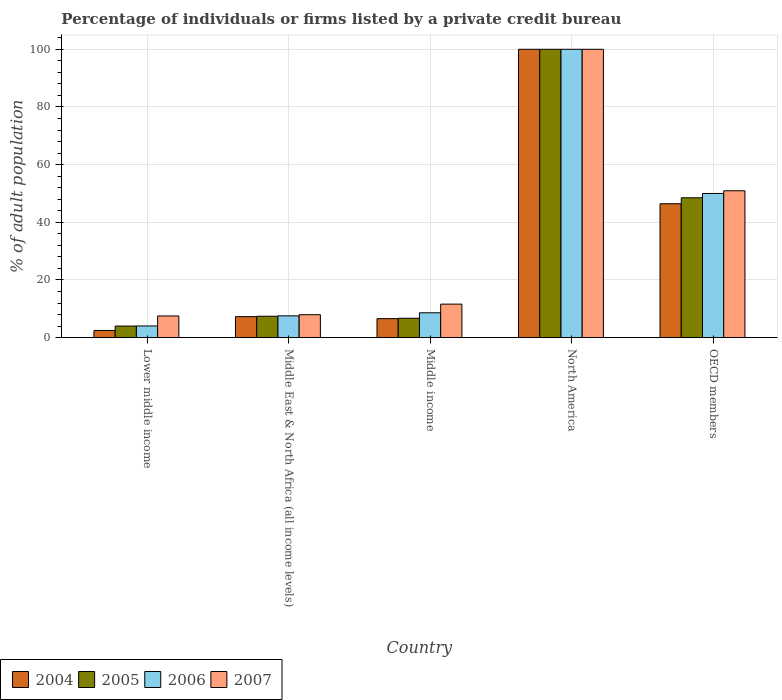How many groups of bars are there?
Offer a terse response. 5. Are the number of bars on each tick of the X-axis equal?
Keep it short and to the point. Yes. How many bars are there on the 1st tick from the left?
Offer a very short reply. 4. How many bars are there on the 4th tick from the right?
Your answer should be very brief. 4. What is the label of the 5th group of bars from the left?
Your answer should be compact. OECD members. In how many cases, is the number of bars for a given country not equal to the number of legend labels?
Your answer should be compact. 0. What is the percentage of population listed by a private credit bureau in 2004 in OECD members?
Offer a very short reply. 46.43. Across all countries, what is the minimum percentage of population listed by a private credit bureau in 2004?
Your response must be concise. 2.5. In which country was the percentage of population listed by a private credit bureau in 2004 maximum?
Provide a succinct answer. North America. In which country was the percentage of population listed by a private credit bureau in 2004 minimum?
Provide a succinct answer. Lower middle income. What is the total percentage of population listed by a private credit bureau in 2006 in the graph?
Ensure brevity in your answer.  170.25. What is the difference between the percentage of population listed by a private credit bureau in 2004 in Middle income and that in OECD members?
Make the answer very short. -39.84. What is the difference between the percentage of population listed by a private credit bureau in 2006 in Middle income and the percentage of population listed by a private credit bureau in 2005 in OECD members?
Keep it short and to the point. -39.88. What is the average percentage of population listed by a private credit bureau in 2004 per country?
Give a very brief answer. 32.56. What is the difference between the percentage of population listed by a private credit bureau of/in 2005 and percentage of population listed by a private credit bureau of/in 2006 in OECD members?
Ensure brevity in your answer.  -1.5. In how many countries, is the percentage of population listed by a private credit bureau in 2005 greater than 92 %?
Provide a succinct answer. 1. What is the ratio of the percentage of population listed by a private credit bureau in 2006 in Middle income to that in OECD members?
Make the answer very short. 0.17. Is the difference between the percentage of population listed by a private credit bureau in 2005 in Lower middle income and Middle East & North Africa (all income levels) greater than the difference between the percentage of population listed by a private credit bureau in 2006 in Lower middle income and Middle East & North Africa (all income levels)?
Provide a succinct answer. Yes. What is the difference between the highest and the second highest percentage of population listed by a private credit bureau in 2006?
Provide a succinct answer. -41.38. What is the difference between the highest and the lowest percentage of population listed by a private credit bureau in 2005?
Your response must be concise. 95.97. Is it the case that in every country, the sum of the percentage of population listed by a private credit bureau in 2006 and percentage of population listed by a private credit bureau in 2007 is greater than the sum of percentage of population listed by a private credit bureau in 2004 and percentage of population listed by a private credit bureau in 2005?
Offer a terse response. No. What does the 1st bar from the right in Middle income represents?
Your response must be concise. 2007. Is it the case that in every country, the sum of the percentage of population listed by a private credit bureau in 2007 and percentage of population listed by a private credit bureau in 2005 is greater than the percentage of population listed by a private credit bureau in 2004?
Make the answer very short. Yes. How many bars are there?
Keep it short and to the point. 20. Are all the bars in the graph horizontal?
Your answer should be compact. No. Does the graph contain grids?
Your answer should be very brief. Yes. What is the title of the graph?
Your answer should be very brief. Percentage of individuals or firms listed by a private credit bureau. What is the label or title of the Y-axis?
Ensure brevity in your answer.  % of adult population. What is the % of adult population of 2004 in Lower middle income?
Give a very brief answer. 2.5. What is the % of adult population in 2005 in Lower middle income?
Provide a short and direct response. 4.03. What is the % of adult population of 2006 in Lower middle income?
Provide a short and direct response. 4.06. What is the % of adult population in 2007 in Lower middle income?
Offer a terse response. 7.53. What is the % of adult population in 2004 in Middle East & North Africa (all income levels)?
Give a very brief answer. 7.29. What is the % of adult population of 2005 in Middle East & North Africa (all income levels)?
Provide a succinct answer. 7.43. What is the % of adult population in 2006 in Middle East & North Africa (all income levels)?
Your answer should be compact. 7.56. What is the % of adult population of 2007 in Middle East & North Africa (all income levels)?
Give a very brief answer. 7.96. What is the % of adult population in 2004 in Middle income?
Your answer should be compact. 6.6. What is the % of adult population in 2005 in Middle income?
Give a very brief answer. 6.73. What is the % of adult population of 2006 in Middle income?
Your answer should be very brief. 8.62. What is the % of adult population of 2007 in Middle income?
Provide a short and direct response. 11.63. What is the % of adult population of 2004 in North America?
Ensure brevity in your answer.  100. What is the % of adult population of 2006 in North America?
Ensure brevity in your answer.  100. What is the % of adult population in 2004 in OECD members?
Provide a succinct answer. 46.43. What is the % of adult population in 2005 in OECD members?
Provide a short and direct response. 48.5. What is the % of adult population of 2006 in OECD members?
Give a very brief answer. 50. What is the % of adult population in 2007 in OECD members?
Your answer should be very brief. 50.95. Across all countries, what is the maximum % of adult population of 2004?
Your answer should be compact. 100. Across all countries, what is the minimum % of adult population of 2004?
Give a very brief answer. 2.5. Across all countries, what is the minimum % of adult population of 2005?
Make the answer very short. 4.03. Across all countries, what is the minimum % of adult population in 2006?
Provide a short and direct response. 4.06. Across all countries, what is the minimum % of adult population in 2007?
Give a very brief answer. 7.53. What is the total % of adult population in 2004 in the graph?
Offer a very short reply. 162.82. What is the total % of adult population in 2005 in the graph?
Provide a succinct answer. 166.69. What is the total % of adult population of 2006 in the graph?
Give a very brief answer. 170.25. What is the total % of adult population of 2007 in the graph?
Give a very brief answer. 178.07. What is the difference between the % of adult population in 2004 in Lower middle income and that in Middle East & North Africa (all income levels)?
Provide a short and direct response. -4.79. What is the difference between the % of adult population in 2005 in Lower middle income and that in Middle East & North Africa (all income levels)?
Keep it short and to the point. -3.4. What is the difference between the % of adult population of 2006 in Lower middle income and that in Middle East & North Africa (all income levels)?
Keep it short and to the point. -3.51. What is the difference between the % of adult population in 2007 in Lower middle income and that in Middle East & North Africa (all income levels)?
Make the answer very short. -0.44. What is the difference between the % of adult population in 2004 in Lower middle income and that in Middle income?
Keep it short and to the point. -4.09. What is the difference between the % of adult population of 2005 in Lower middle income and that in Middle income?
Offer a terse response. -2.7. What is the difference between the % of adult population of 2006 in Lower middle income and that in Middle income?
Your answer should be compact. -4.57. What is the difference between the % of adult population in 2007 in Lower middle income and that in Middle income?
Make the answer very short. -4.11. What is the difference between the % of adult population in 2004 in Lower middle income and that in North America?
Your answer should be very brief. -97.5. What is the difference between the % of adult population in 2005 in Lower middle income and that in North America?
Keep it short and to the point. -95.97. What is the difference between the % of adult population in 2006 in Lower middle income and that in North America?
Give a very brief answer. -95.94. What is the difference between the % of adult population of 2007 in Lower middle income and that in North America?
Make the answer very short. -92.47. What is the difference between the % of adult population of 2004 in Lower middle income and that in OECD members?
Ensure brevity in your answer.  -43.93. What is the difference between the % of adult population of 2005 in Lower middle income and that in OECD members?
Provide a succinct answer. -44.48. What is the difference between the % of adult population of 2006 in Lower middle income and that in OECD members?
Your answer should be compact. -45.94. What is the difference between the % of adult population of 2007 in Lower middle income and that in OECD members?
Make the answer very short. -43.42. What is the difference between the % of adult population in 2004 in Middle East & North Africa (all income levels) and that in Middle income?
Provide a short and direct response. 0.69. What is the difference between the % of adult population in 2005 in Middle East & North Africa (all income levels) and that in Middle income?
Keep it short and to the point. 0.7. What is the difference between the % of adult population of 2006 in Middle East & North Africa (all income levels) and that in Middle income?
Offer a terse response. -1.06. What is the difference between the % of adult population of 2007 in Middle East & North Africa (all income levels) and that in Middle income?
Keep it short and to the point. -3.67. What is the difference between the % of adult population of 2004 in Middle East & North Africa (all income levels) and that in North America?
Ensure brevity in your answer.  -92.71. What is the difference between the % of adult population of 2005 in Middle East & North Africa (all income levels) and that in North America?
Your answer should be compact. -92.57. What is the difference between the % of adult population in 2006 in Middle East & North Africa (all income levels) and that in North America?
Provide a short and direct response. -92.44. What is the difference between the % of adult population in 2007 in Middle East & North Africa (all income levels) and that in North America?
Your response must be concise. -92.04. What is the difference between the % of adult population in 2004 in Middle East & North Africa (all income levels) and that in OECD members?
Your response must be concise. -39.15. What is the difference between the % of adult population in 2005 in Middle East & North Africa (all income levels) and that in OECD members?
Your answer should be compact. -41.07. What is the difference between the % of adult population of 2006 in Middle East & North Africa (all income levels) and that in OECD members?
Provide a succinct answer. -42.44. What is the difference between the % of adult population in 2007 in Middle East & North Africa (all income levels) and that in OECD members?
Ensure brevity in your answer.  -42.98. What is the difference between the % of adult population of 2004 in Middle income and that in North America?
Your response must be concise. -93.4. What is the difference between the % of adult population of 2005 in Middle income and that in North America?
Your answer should be compact. -93.27. What is the difference between the % of adult population in 2006 in Middle income and that in North America?
Provide a short and direct response. -91.38. What is the difference between the % of adult population of 2007 in Middle income and that in North America?
Your answer should be compact. -88.37. What is the difference between the % of adult population in 2004 in Middle income and that in OECD members?
Your response must be concise. -39.84. What is the difference between the % of adult population in 2005 in Middle income and that in OECD members?
Offer a terse response. -41.77. What is the difference between the % of adult population in 2006 in Middle income and that in OECD members?
Ensure brevity in your answer.  -41.38. What is the difference between the % of adult population of 2007 in Middle income and that in OECD members?
Provide a succinct answer. -39.31. What is the difference between the % of adult population of 2004 in North America and that in OECD members?
Provide a short and direct response. 53.57. What is the difference between the % of adult population in 2005 in North America and that in OECD members?
Offer a terse response. 51.5. What is the difference between the % of adult population in 2007 in North America and that in OECD members?
Your response must be concise. 49.05. What is the difference between the % of adult population in 2004 in Lower middle income and the % of adult population in 2005 in Middle East & North Africa (all income levels)?
Keep it short and to the point. -4.93. What is the difference between the % of adult population of 2004 in Lower middle income and the % of adult population of 2006 in Middle East & North Africa (all income levels)?
Provide a succinct answer. -5.06. What is the difference between the % of adult population in 2004 in Lower middle income and the % of adult population in 2007 in Middle East & North Africa (all income levels)?
Offer a terse response. -5.46. What is the difference between the % of adult population in 2005 in Lower middle income and the % of adult population in 2006 in Middle East & North Africa (all income levels)?
Ensure brevity in your answer.  -3.54. What is the difference between the % of adult population in 2005 in Lower middle income and the % of adult population in 2007 in Middle East & North Africa (all income levels)?
Your answer should be compact. -3.94. What is the difference between the % of adult population in 2006 in Lower middle income and the % of adult population in 2007 in Middle East & North Africa (all income levels)?
Offer a very short reply. -3.9. What is the difference between the % of adult population of 2004 in Lower middle income and the % of adult population of 2005 in Middle income?
Your answer should be very brief. -4.23. What is the difference between the % of adult population of 2004 in Lower middle income and the % of adult population of 2006 in Middle income?
Provide a succinct answer. -6.12. What is the difference between the % of adult population in 2004 in Lower middle income and the % of adult population in 2007 in Middle income?
Offer a terse response. -9.13. What is the difference between the % of adult population in 2005 in Lower middle income and the % of adult population in 2006 in Middle income?
Ensure brevity in your answer.  -4.6. What is the difference between the % of adult population of 2005 in Lower middle income and the % of adult population of 2007 in Middle income?
Provide a short and direct response. -7.61. What is the difference between the % of adult population of 2006 in Lower middle income and the % of adult population of 2007 in Middle income?
Keep it short and to the point. -7.58. What is the difference between the % of adult population in 2004 in Lower middle income and the % of adult population in 2005 in North America?
Give a very brief answer. -97.5. What is the difference between the % of adult population of 2004 in Lower middle income and the % of adult population of 2006 in North America?
Make the answer very short. -97.5. What is the difference between the % of adult population in 2004 in Lower middle income and the % of adult population in 2007 in North America?
Offer a very short reply. -97.5. What is the difference between the % of adult population in 2005 in Lower middle income and the % of adult population in 2006 in North America?
Make the answer very short. -95.97. What is the difference between the % of adult population of 2005 in Lower middle income and the % of adult population of 2007 in North America?
Ensure brevity in your answer.  -95.97. What is the difference between the % of adult population of 2006 in Lower middle income and the % of adult population of 2007 in North America?
Your answer should be compact. -95.94. What is the difference between the % of adult population in 2004 in Lower middle income and the % of adult population in 2005 in OECD members?
Make the answer very short. -46. What is the difference between the % of adult population in 2004 in Lower middle income and the % of adult population in 2006 in OECD members?
Give a very brief answer. -47.5. What is the difference between the % of adult population of 2004 in Lower middle income and the % of adult population of 2007 in OECD members?
Offer a very short reply. -48.44. What is the difference between the % of adult population of 2005 in Lower middle income and the % of adult population of 2006 in OECD members?
Provide a succinct answer. -45.98. What is the difference between the % of adult population of 2005 in Lower middle income and the % of adult population of 2007 in OECD members?
Your response must be concise. -46.92. What is the difference between the % of adult population in 2006 in Lower middle income and the % of adult population in 2007 in OECD members?
Ensure brevity in your answer.  -46.89. What is the difference between the % of adult population of 2004 in Middle East & North Africa (all income levels) and the % of adult population of 2005 in Middle income?
Offer a very short reply. 0.56. What is the difference between the % of adult population of 2004 in Middle East & North Africa (all income levels) and the % of adult population of 2006 in Middle income?
Make the answer very short. -1.34. What is the difference between the % of adult population in 2004 in Middle East & North Africa (all income levels) and the % of adult population in 2007 in Middle income?
Keep it short and to the point. -4.35. What is the difference between the % of adult population of 2005 in Middle East & North Africa (all income levels) and the % of adult population of 2006 in Middle income?
Ensure brevity in your answer.  -1.2. What is the difference between the % of adult population of 2005 in Middle East & North Africa (all income levels) and the % of adult population of 2007 in Middle income?
Make the answer very short. -4.21. What is the difference between the % of adult population in 2006 in Middle East & North Africa (all income levels) and the % of adult population in 2007 in Middle income?
Offer a terse response. -4.07. What is the difference between the % of adult population of 2004 in Middle East & North Africa (all income levels) and the % of adult population of 2005 in North America?
Ensure brevity in your answer.  -92.71. What is the difference between the % of adult population of 2004 in Middle East & North Africa (all income levels) and the % of adult population of 2006 in North America?
Your response must be concise. -92.71. What is the difference between the % of adult population of 2004 in Middle East & North Africa (all income levels) and the % of adult population of 2007 in North America?
Your response must be concise. -92.71. What is the difference between the % of adult population of 2005 in Middle East & North Africa (all income levels) and the % of adult population of 2006 in North America?
Make the answer very short. -92.57. What is the difference between the % of adult population of 2005 in Middle East & North Africa (all income levels) and the % of adult population of 2007 in North America?
Give a very brief answer. -92.57. What is the difference between the % of adult population of 2006 in Middle East & North Africa (all income levels) and the % of adult population of 2007 in North America?
Your response must be concise. -92.44. What is the difference between the % of adult population of 2004 in Middle East & North Africa (all income levels) and the % of adult population of 2005 in OECD members?
Provide a short and direct response. -41.22. What is the difference between the % of adult population in 2004 in Middle East & North Africa (all income levels) and the % of adult population in 2006 in OECD members?
Offer a terse response. -42.71. What is the difference between the % of adult population of 2004 in Middle East & North Africa (all income levels) and the % of adult population of 2007 in OECD members?
Your answer should be very brief. -43.66. What is the difference between the % of adult population of 2005 in Middle East & North Africa (all income levels) and the % of adult population of 2006 in OECD members?
Provide a succinct answer. -42.57. What is the difference between the % of adult population of 2005 in Middle East & North Africa (all income levels) and the % of adult population of 2007 in OECD members?
Your answer should be very brief. -43.52. What is the difference between the % of adult population of 2006 in Middle East & North Africa (all income levels) and the % of adult population of 2007 in OECD members?
Offer a very short reply. -43.38. What is the difference between the % of adult population in 2004 in Middle income and the % of adult population in 2005 in North America?
Ensure brevity in your answer.  -93.4. What is the difference between the % of adult population in 2004 in Middle income and the % of adult population in 2006 in North America?
Provide a succinct answer. -93.4. What is the difference between the % of adult population of 2004 in Middle income and the % of adult population of 2007 in North America?
Provide a succinct answer. -93.4. What is the difference between the % of adult population of 2005 in Middle income and the % of adult population of 2006 in North America?
Give a very brief answer. -93.27. What is the difference between the % of adult population in 2005 in Middle income and the % of adult population in 2007 in North America?
Keep it short and to the point. -93.27. What is the difference between the % of adult population in 2006 in Middle income and the % of adult population in 2007 in North America?
Your answer should be compact. -91.38. What is the difference between the % of adult population of 2004 in Middle income and the % of adult population of 2005 in OECD members?
Offer a terse response. -41.91. What is the difference between the % of adult population of 2004 in Middle income and the % of adult population of 2006 in OECD members?
Provide a short and direct response. -43.4. What is the difference between the % of adult population in 2004 in Middle income and the % of adult population in 2007 in OECD members?
Make the answer very short. -44.35. What is the difference between the % of adult population of 2005 in Middle income and the % of adult population of 2006 in OECD members?
Ensure brevity in your answer.  -43.27. What is the difference between the % of adult population in 2005 in Middle income and the % of adult population in 2007 in OECD members?
Provide a short and direct response. -44.22. What is the difference between the % of adult population of 2006 in Middle income and the % of adult population of 2007 in OECD members?
Offer a terse response. -42.32. What is the difference between the % of adult population in 2004 in North America and the % of adult population in 2005 in OECD members?
Ensure brevity in your answer.  51.5. What is the difference between the % of adult population of 2004 in North America and the % of adult population of 2006 in OECD members?
Provide a short and direct response. 50. What is the difference between the % of adult population in 2004 in North America and the % of adult population in 2007 in OECD members?
Your answer should be very brief. 49.05. What is the difference between the % of adult population in 2005 in North America and the % of adult population in 2007 in OECD members?
Keep it short and to the point. 49.05. What is the difference between the % of adult population of 2006 in North America and the % of adult population of 2007 in OECD members?
Offer a very short reply. 49.05. What is the average % of adult population in 2004 per country?
Offer a very short reply. 32.56. What is the average % of adult population of 2005 per country?
Your answer should be very brief. 33.34. What is the average % of adult population of 2006 per country?
Make the answer very short. 34.05. What is the average % of adult population of 2007 per country?
Offer a very short reply. 35.61. What is the difference between the % of adult population of 2004 and % of adult population of 2005 in Lower middle income?
Provide a short and direct response. -1.52. What is the difference between the % of adult population in 2004 and % of adult population in 2006 in Lower middle income?
Make the answer very short. -1.56. What is the difference between the % of adult population in 2004 and % of adult population in 2007 in Lower middle income?
Give a very brief answer. -5.02. What is the difference between the % of adult population of 2005 and % of adult population of 2006 in Lower middle income?
Provide a short and direct response. -0.03. What is the difference between the % of adult population of 2006 and % of adult population of 2007 in Lower middle income?
Offer a terse response. -3.47. What is the difference between the % of adult population of 2004 and % of adult population of 2005 in Middle East & North Africa (all income levels)?
Keep it short and to the point. -0.14. What is the difference between the % of adult population of 2004 and % of adult population of 2006 in Middle East & North Africa (all income levels)?
Make the answer very short. -0.28. What is the difference between the % of adult population of 2004 and % of adult population of 2007 in Middle East & North Africa (all income levels)?
Your response must be concise. -0.68. What is the difference between the % of adult population of 2005 and % of adult population of 2006 in Middle East & North Africa (all income levels)?
Provide a short and direct response. -0.14. What is the difference between the % of adult population of 2005 and % of adult population of 2007 in Middle East & North Africa (all income levels)?
Provide a succinct answer. -0.53. What is the difference between the % of adult population of 2006 and % of adult population of 2007 in Middle East & North Africa (all income levels)?
Offer a terse response. -0.4. What is the difference between the % of adult population in 2004 and % of adult population in 2005 in Middle income?
Make the answer very short. -0.13. What is the difference between the % of adult population in 2004 and % of adult population in 2006 in Middle income?
Offer a terse response. -2.03. What is the difference between the % of adult population of 2004 and % of adult population of 2007 in Middle income?
Offer a very short reply. -5.04. What is the difference between the % of adult population of 2005 and % of adult population of 2006 in Middle income?
Offer a terse response. -1.9. What is the difference between the % of adult population in 2005 and % of adult population in 2007 in Middle income?
Provide a short and direct response. -4.91. What is the difference between the % of adult population in 2006 and % of adult population in 2007 in Middle income?
Offer a terse response. -3.01. What is the difference between the % of adult population of 2004 and % of adult population of 2006 in North America?
Give a very brief answer. 0. What is the difference between the % of adult population of 2006 and % of adult population of 2007 in North America?
Ensure brevity in your answer.  0. What is the difference between the % of adult population of 2004 and % of adult population of 2005 in OECD members?
Your response must be concise. -2.07. What is the difference between the % of adult population of 2004 and % of adult population of 2006 in OECD members?
Offer a very short reply. -3.57. What is the difference between the % of adult population of 2004 and % of adult population of 2007 in OECD members?
Your answer should be compact. -4.51. What is the difference between the % of adult population of 2005 and % of adult population of 2006 in OECD members?
Give a very brief answer. -1.5. What is the difference between the % of adult population in 2005 and % of adult population in 2007 in OECD members?
Keep it short and to the point. -2.44. What is the difference between the % of adult population of 2006 and % of adult population of 2007 in OECD members?
Your answer should be compact. -0.95. What is the ratio of the % of adult population in 2004 in Lower middle income to that in Middle East & North Africa (all income levels)?
Your response must be concise. 0.34. What is the ratio of the % of adult population in 2005 in Lower middle income to that in Middle East & North Africa (all income levels)?
Keep it short and to the point. 0.54. What is the ratio of the % of adult population of 2006 in Lower middle income to that in Middle East & North Africa (all income levels)?
Offer a very short reply. 0.54. What is the ratio of the % of adult population in 2007 in Lower middle income to that in Middle East & North Africa (all income levels)?
Offer a terse response. 0.94. What is the ratio of the % of adult population of 2004 in Lower middle income to that in Middle income?
Keep it short and to the point. 0.38. What is the ratio of the % of adult population of 2005 in Lower middle income to that in Middle income?
Give a very brief answer. 0.6. What is the ratio of the % of adult population of 2006 in Lower middle income to that in Middle income?
Your response must be concise. 0.47. What is the ratio of the % of adult population in 2007 in Lower middle income to that in Middle income?
Provide a succinct answer. 0.65. What is the ratio of the % of adult population in 2004 in Lower middle income to that in North America?
Ensure brevity in your answer.  0.03. What is the ratio of the % of adult population of 2005 in Lower middle income to that in North America?
Make the answer very short. 0.04. What is the ratio of the % of adult population in 2006 in Lower middle income to that in North America?
Make the answer very short. 0.04. What is the ratio of the % of adult population in 2007 in Lower middle income to that in North America?
Your answer should be compact. 0.08. What is the ratio of the % of adult population in 2004 in Lower middle income to that in OECD members?
Provide a short and direct response. 0.05. What is the ratio of the % of adult population of 2005 in Lower middle income to that in OECD members?
Make the answer very short. 0.08. What is the ratio of the % of adult population of 2006 in Lower middle income to that in OECD members?
Your response must be concise. 0.08. What is the ratio of the % of adult population in 2007 in Lower middle income to that in OECD members?
Keep it short and to the point. 0.15. What is the ratio of the % of adult population of 2004 in Middle East & North Africa (all income levels) to that in Middle income?
Your response must be concise. 1.1. What is the ratio of the % of adult population in 2005 in Middle East & North Africa (all income levels) to that in Middle income?
Your answer should be compact. 1.1. What is the ratio of the % of adult population in 2006 in Middle East & North Africa (all income levels) to that in Middle income?
Provide a succinct answer. 0.88. What is the ratio of the % of adult population in 2007 in Middle East & North Africa (all income levels) to that in Middle income?
Offer a terse response. 0.68. What is the ratio of the % of adult population of 2004 in Middle East & North Africa (all income levels) to that in North America?
Keep it short and to the point. 0.07. What is the ratio of the % of adult population of 2005 in Middle East & North Africa (all income levels) to that in North America?
Your response must be concise. 0.07. What is the ratio of the % of adult population of 2006 in Middle East & North Africa (all income levels) to that in North America?
Your response must be concise. 0.08. What is the ratio of the % of adult population in 2007 in Middle East & North Africa (all income levels) to that in North America?
Provide a succinct answer. 0.08. What is the ratio of the % of adult population of 2004 in Middle East & North Africa (all income levels) to that in OECD members?
Offer a very short reply. 0.16. What is the ratio of the % of adult population of 2005 in Middle East & North Africa (all income levels) to that in OECD members?
Keep it short and to the point. 0.15. What is the ratio of the % of adult population in 2006 in Middle East & North Africa (all income levels) to that in OECD members?
Your response must be concise. 0.15. What is the ratio of the % of adult population in 2007 in Middle East & North Africa (all income levels) to that in OECD members?
Make the answer very short. 0.16. What is the ratio of the % of adult population of 2004 in Middle income to that in North America?
Offer a very short reply. 0.07. What is the ratio of the % of adult population of 2005 in Middle income to that in North America?
Give a very brief answer. 0.07. What is the ratio of the % of adult population of 2006 in Middle income to that in North America?
Provide a succinct answer. 0.09. What is the ratio of the % of adult population in 2007 in Middle income to that in North America?
Make the answer very short. 0.12. What is the ratio of the % of adult population in 2004 in Middle income to that in OECD members?
Ensure brevity in your answer.  0.14. What is the ratio of the % of adult population in 2005 in Middle income to that in OECD members?
Your answer should be very brief. 0.14. What is the ratio of the % of adult population in 2006 in Middle income to that in OECD members?
Offer a terse response. 0.17. What is the ratio of the % of adult population of 2007 in Middle income to that in OECD members?
Keep it short and to the point. 0.23. What is the ratio of the % of adult population of 2004 in North America to that in OECD members?
Give a very brief answer. 2.15. What is the ratio of the % of adult population of 2005 in North America to that in OECD members?
Give a very brief answer. 2.06. What is the ratio of the % of adult population in 2006 in North America to that in OECD members?
Your answer should be very brief. 2. What is the ratio of the % of adult population of 2007 in North America to that in OECD members?
Your answer should be very brief. 1.96. What is the difference between the highest and the second highest % of adult population in 2004?
Offer a very short reply. 53.57. What is the difference between the highest and the second highest % of adult population of 2005?
Provide a short and direct response. 51.5. What is the difference between the highest and the second highest % of adult population of 2007?
Offer a terse response. 49.05. What is the difference between the highest and the lowest % of adult population of 2004?
Keep it short and to the point. 97.5. What is the difference between the highest and the lowest % of adult population of 2005?
Make the answer very short. 95.97. What is the difference between the highest and the lowest % of adult population of 2006?
Provide a succinct answer. 95.94. What is the difference between the highest and the lowest % of adult population of 2007?
Provide a short and direct response. 92.47. 